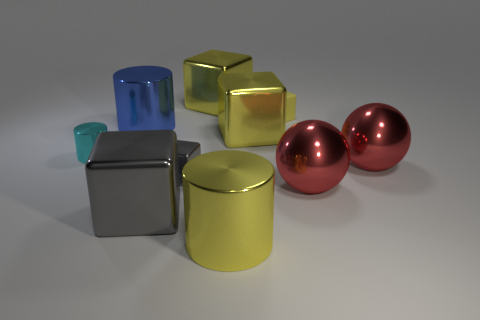Subtract all red balls. How many yellow blocks are left? 3 Subtract all tiny matte blocks. How many blocks are left? 4 Subtract all green cubes. Subtract all gray cylinders. How many cubes are left? 5 Subtract all balls. How many objects are left? 8 Add 3 tiny blocks. How many tiny blocks exist? 5 Subtract 0 cyan blocks. How many objects are left? 10 Subtract all big spheres. Subtract all big yellow cylinders. How many objects are left? 7 Add 7 yellow cylinders. How many yellow cylinders are left? 8 